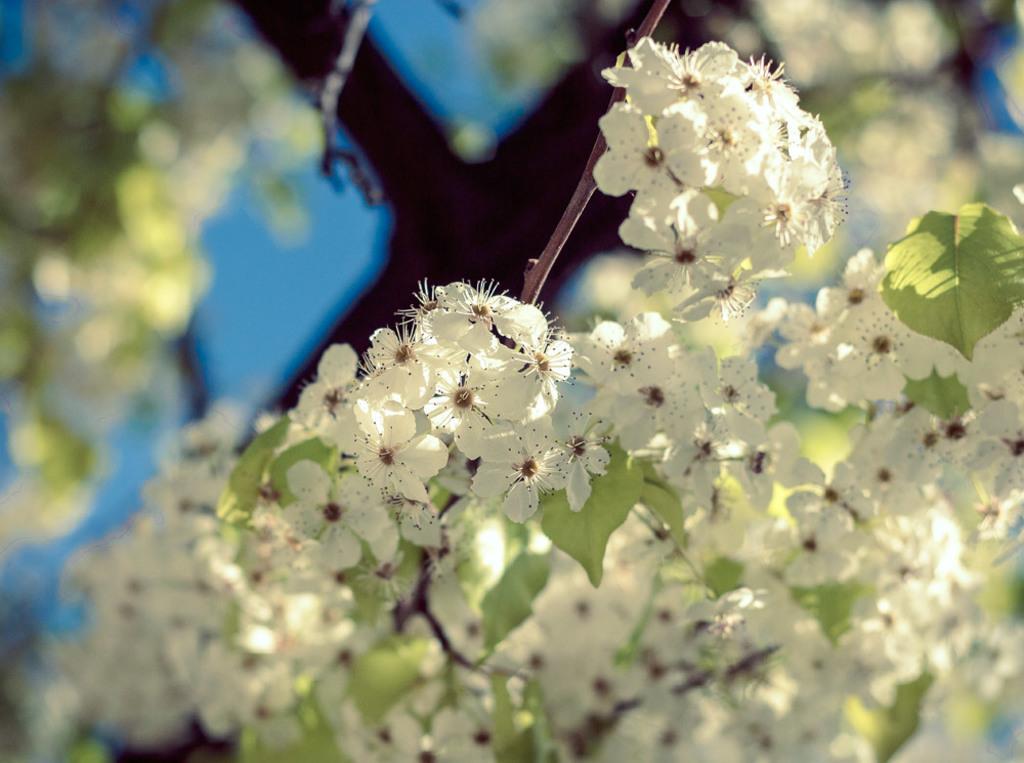Could you give a brief overview of what you see in this image? In this picture there are white color flowers and green color leaves on the plant. At the top there is sky. 